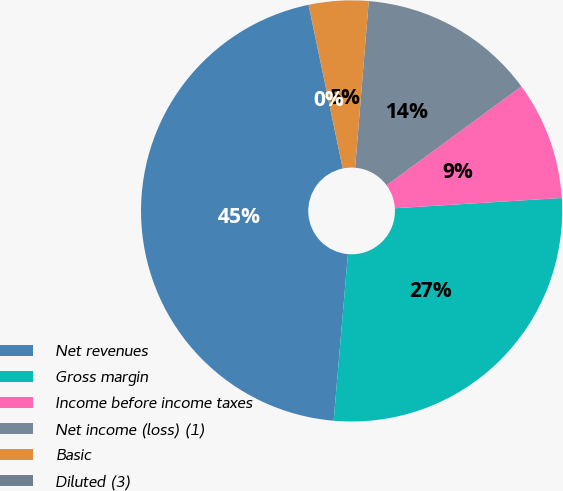<chart> <loc_0><loc_0><loc_500><loc_500><pie_chart><fcel>Net revenues<fcel>Gross margin<fcel>Income before income taxes<fcel>Net income (loss) (1)<fcel>Basic<fcel>Diluted (3)<nl><fcel>45.36%<fcel>27.34%<fcel>9.09%<fcel>13.63%<fcel>4.56%<fcel>0.02%<nl></chart> 